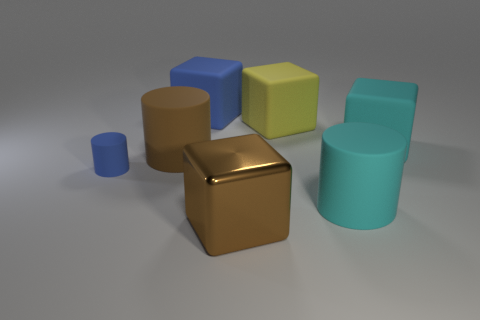Is there a cyan cylinder that is on the right side of the blue thing that is in front of the brown object behind the brown block?
Your answer should be very brief. Yes. What number of large objects are either blue matte cubes or brown cubes?
Your answer should be very brief. 2. There is a metallic thing that is the same size as the cyan block; what color is it?
Provide a succinct answer. Brown. There is a large metallic thing; what number of tiny cylinders are right of it?
Ensure brevity in your answer.  0. Are there any other things that have the same material as the large yellow thing?
Offer a terse response. Yes. The matte thing that is the same color as the large metallic cube is what shape?
Your answer should be very brief. Cylinder. What color is the big matte block that is behind the large yellow block?
Your answer should be very brief. Blue. Is the number of big blue cubes to the left of the small blue rubber cylinder the same as the number of large blue cubes that are on the left side of the brown matte object?
Provide a short and direct response. Yes. There is a brown block to the right of the matte block to the left of the brown cube; what is its material?
Your answer should be very brief. Metal. How many things are matte blocks or brown things in front of the tiny thing?
Offer a terse response. 4. 